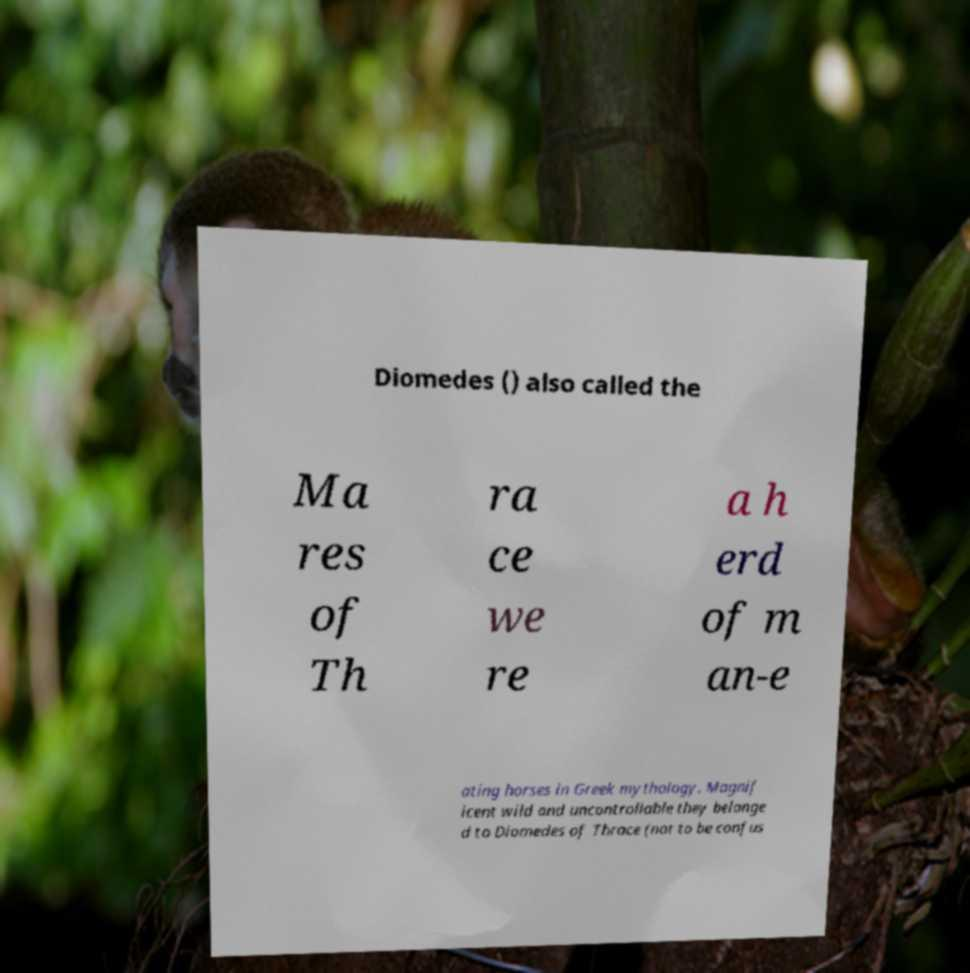I need the written content from this picture converted into text. Can you do that? Diomedes () also called the Ma res of Th ra ce we re a h erd of m an-e ating horses in Greek mythology. Magnif icent wild and uncontrollable they belonge d to Diomedes of Thrace (not to be confus 